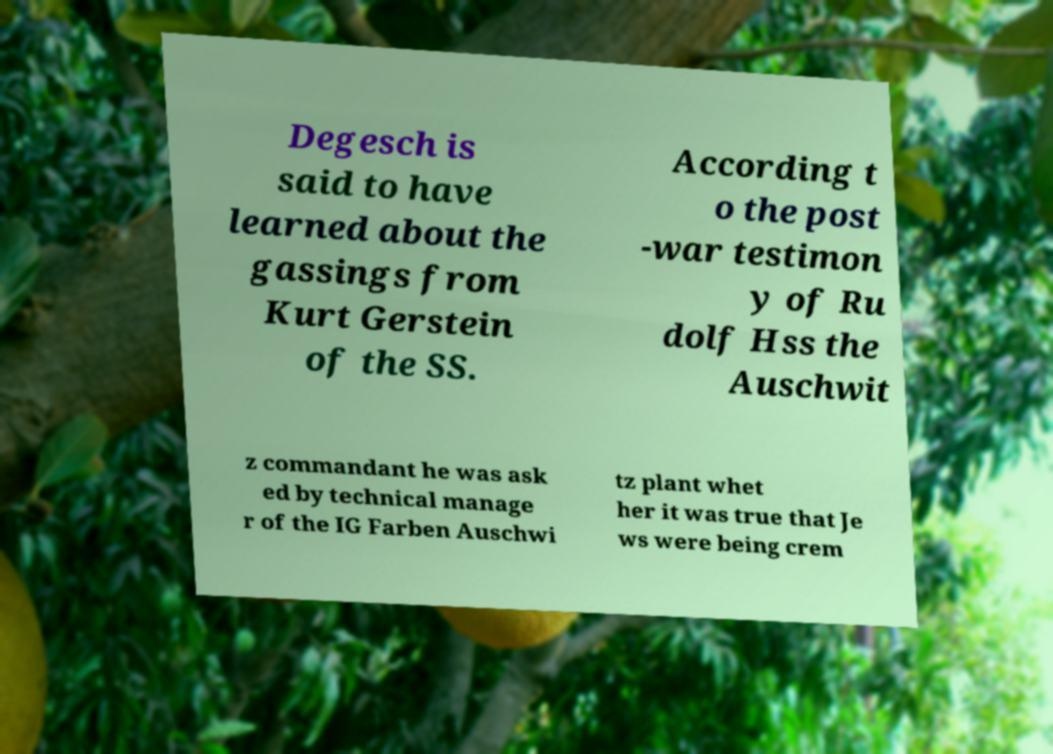For documentation purposes, I need the text within this image transcribed. Could you provide that? Degesch is said to have learned about the gassings from Kurt Gerstein of the SS. According t o the post -war testimon y of Ru dolf Hss the Auschwit z commandant he was ask ed by technical manage r of the IG Farben Auschwi tz plant whet her it was true that Je ws were being crem 